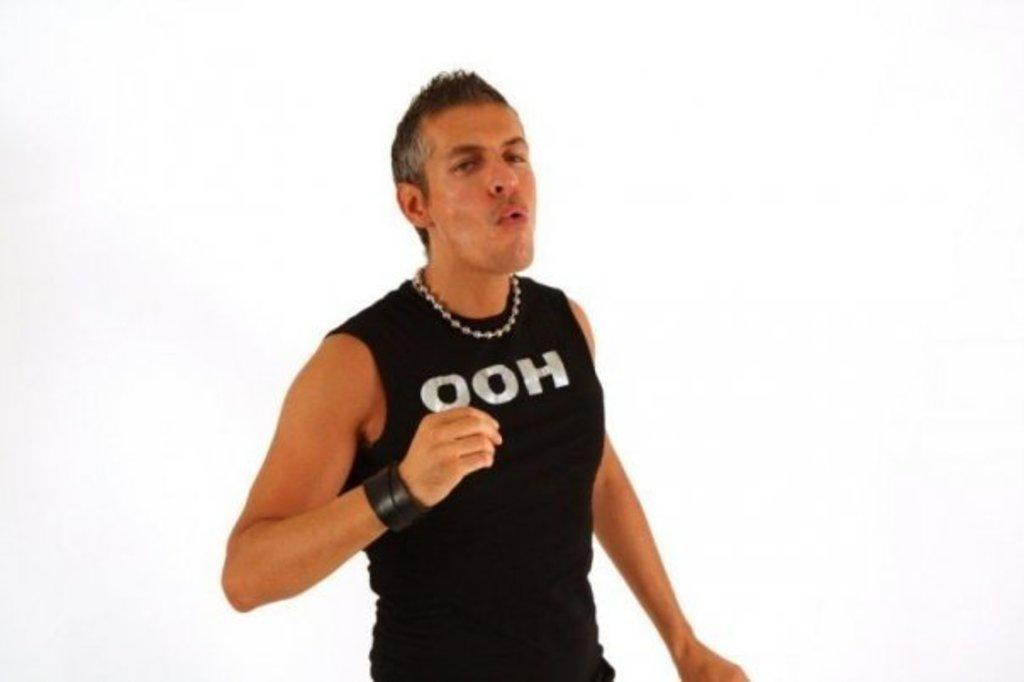<image>
Write a terse but informative summary of the picture. Man with the words ooh wrote on his black tank top shirt 